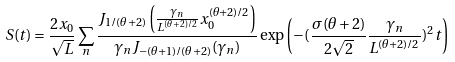<formula> <loc_0><loc_0><loc_500><loc_500>S ( t ) = \frac { 2 x _ { 0 } } { \sqrt { L } } \sum _ { n } \frac { J _ { 1 / ( \theta + 2 ) } \left ( \frac { \gamma _ { n } } { L ^ { ( \theta + 2 ) / 2 } } x _ { 0 } ^ { ( \theta + 2 ) / 2 } \right ) } { \gamma _ { n } J _ { - ( \theta + 1 ) / ( \theta + 2 ) } ( \gamma _ { n } ) } \exp \left ( - ( \frac { \sigma ( \theta + 2 ) } { 2 \sqrt { 2 } } \frac { \gamma _ { n } } { L ^ { ( \theta + 2 ) / 2 } } ) ^ { 2 } t \right )</formula> 